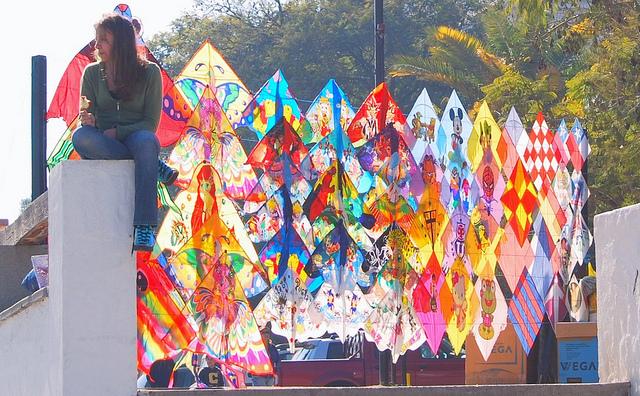Can those items fly?
Answer briefly. Yes. Is she selling these objects?
Short answer required. Yes. What is the woman sitting on?
Be succinct. Wall. What would the vertical standing items be used for?
Answer briefly. Flying. 